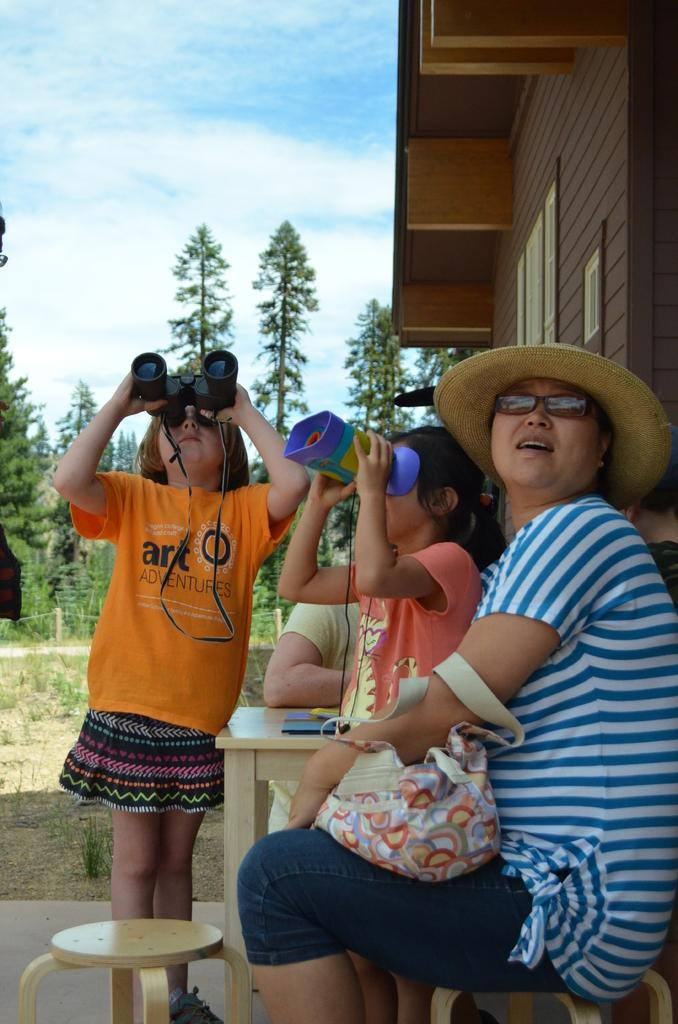How many people are in the image? There is a group of people in the image. What type of structure is visible in the image? There is a house in the image. What can be seen in the sky in the image? The sky is visible in the image. What type of vegetation is present in the image? There are trees in the image. How many chairs are being knitted by the girls in the image? There are no girls or chairs present in the image. 